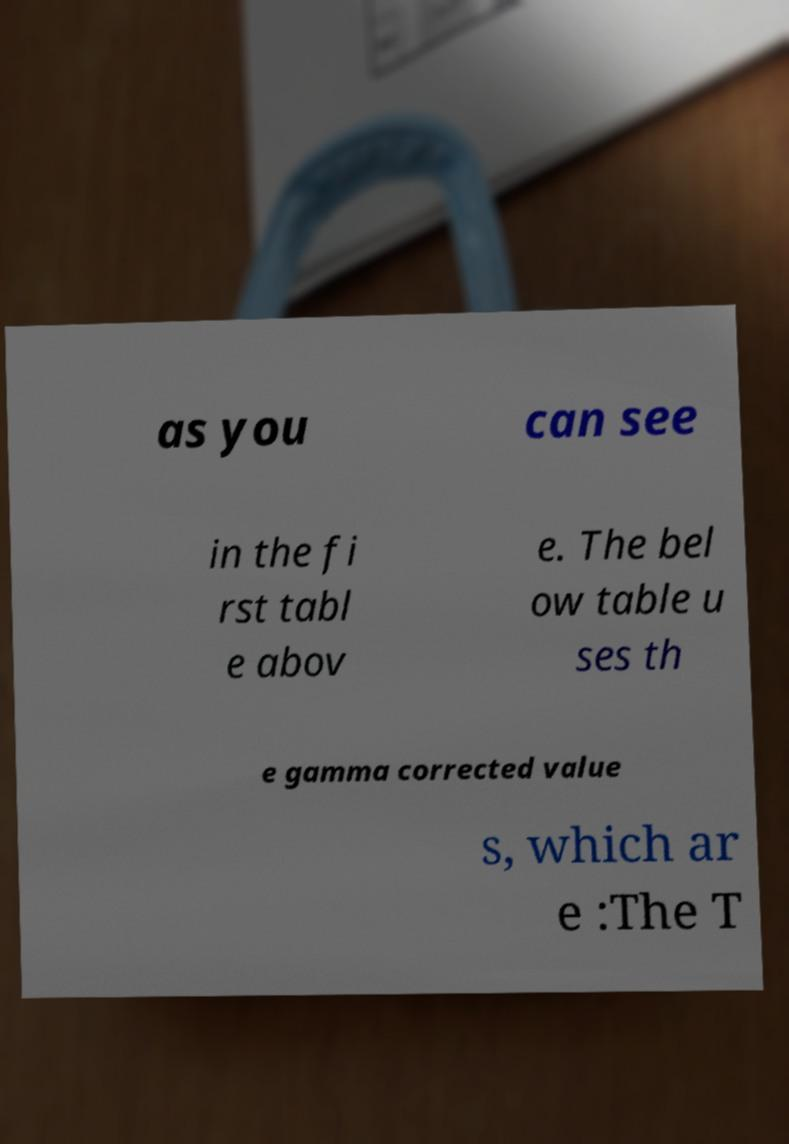Can you read and provide the text displayed in the image?This photo seems to have some interesting text. Can you extract and type it out for me? as you can see in the fi rst tabl e abov e. The bel ow table u ses th e gamma corrected value s, which ar e :The T 